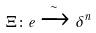<formula> <loc_0><loc_0><loc_500><loc_500>\Xi \colon e \xrightarrow { \sim } \delta ^ { n }</formula> 